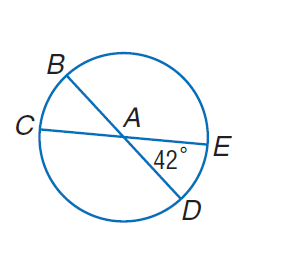Answer the mathemtical geometry problem and directly provide the correct option letter.
Question: In \odot A, m \angle E A D = 42. Find m \widehat C D.
Choices: A: 138 B: 142 C: 240 D: 360 A 